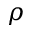<formula> <loc_0><loc_0><loc_500><loc_500>\rho</formula> 